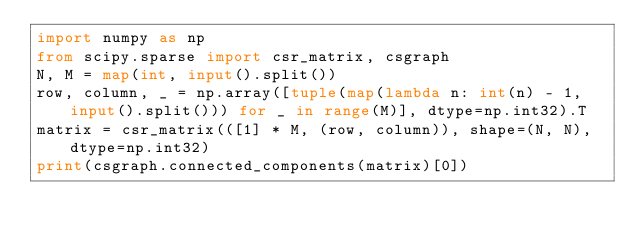<code> <loc_0><loc_0><loc_500><loc_500><_Python_>import numpy as np
from scipy.sparse import csr_matrix, csgraph
N, M = map(int, input().split())
row, column, _ = np.array([tuple(map(lambda n: int(n) - 1, input().split())) for _ in range(M)], dtype=np.int32).T
matrix = csr_matrix(([1] * M, (row, column)), shape=(N, N), dtype=np.int32)
print(csgraph.connected_components(matrix)[0])
</code> 